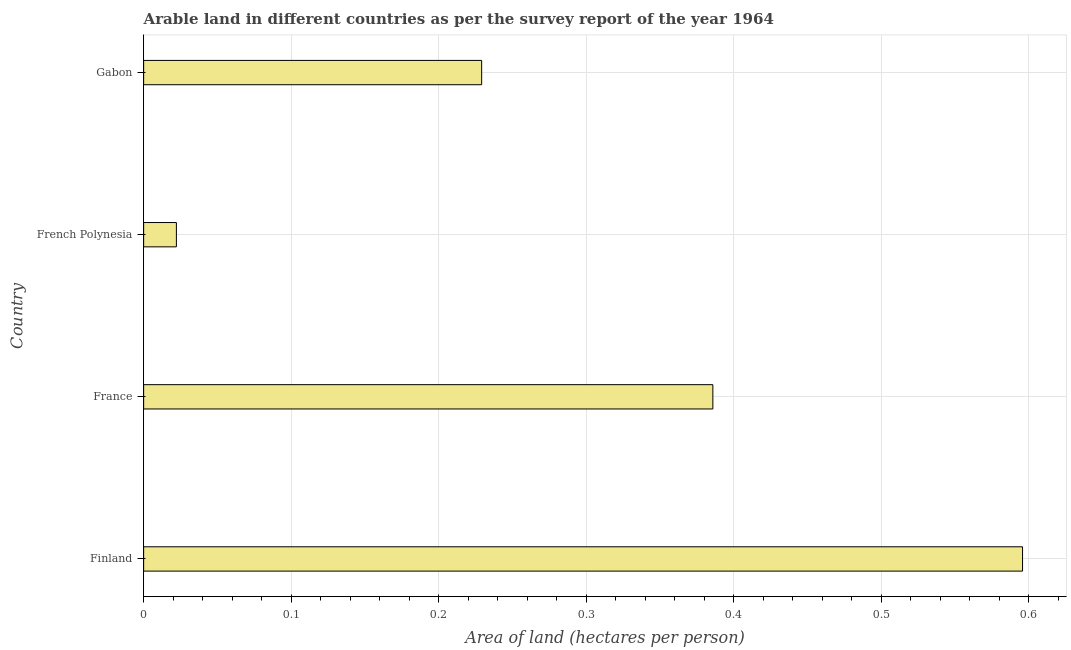Does the graph contain grids?
Provide a short and direct response. Yes. What is the title of the graph?
Offer a terse response. Arable land in different countries as per the survey report of the year 1964. What is the label or title of the X-axis?
Offer a terse response. Area of land (hectares per person). What is the area of arable land in Gabon?
Your answer should be very brief. 0.23. Across all countries, what is the maximum area of arable land?
Offer a very short reply. 0.6. Across all countries, what is the minimum area of arable land?
Give a very brief answer. 0.02. In which country was the area of arable land maximum?
Your answer should be very brief. Finland. In which country was the area of arable land minimum?
Your answer should be compact. French Polynesia. What is the sum of the area of arable land?
Your response must be concise. 1.23. What is the difference between the area of arable land in France and French Polynesia?
Provide a succinct answer. 0.36. What is the average area of arable land per country?
Offer a terse response. 0.31. What is the median area of arable land?
Make the answer very short. 0.31. What is the ratio of the area of arable land in Finland to that in French Polynesia?
Offer a very short reply. 26.85. Is the difference between the area of arable land in France and French Polynesia greater than the difference between any two countries?
Provide a succinct answer. No. What is the difference between the highest and the second highest area of arable land?
Your answer should be compact. 0.21. What is the difference between the highest and the lowest area of arable land?
Provide a succinct answer. 0.57. How many bars are there?
Offer a terse response. 4. Are all the bars in the graph horizontal?
Keep it short and to the point. Yes. How many countries are there in the graph?
Make the answer very short. 4. Are the values on the major ticks of X-axis written in scientific E-notation?
Offer a terse response. No. What is the Area of land (hectares per person) of Finland?
Your answer should be very brief. 0.6. What is the Area of land (hectares per person) of France?
Provide a succinct answer. 0.39. What is the Area of land (hectares per person) in French Polynesia?
Keep it short and to the point. 0.02. What is the Area of land (hectares per person) in Gabon?
Keep it short and to the point. 0.23. What is the difference between the Area of land (hectares per person) in Finland and France?
Provide a short and direct response. 0.21. What is the difference between the Area of land (hectares per person) in Finland and French Polynesia?
Ensure brevity in your answer.  0.57. What is the difference between the Area of land (hectares per person) in Finland and Gabon?
Keep it short and to the point. 0.37. What is the difference between the Area of land (hectares per person) in France and French Polynesia?
Provide a short and direct response. 0.36. What is the difference between the Area of land (hectares per person) in France and Gabon?
Keep it short and to the point. 0.16. What is the difference between the Area of land (hectares per person) in French Polynesia and Gabon?
Your answer should be compact. -0.21. What is the ratio of the Area of land (hectares per person) in Finland to that in France?
Offer a terse response. 1.54. What is the ratio of the Area of land (hectares per person) in Finland to that in French Polynesia?
Your answer should be compact. 26.85. What is the ratio of the Area of land (hectares per person) in Finland to that in Gabon?
Your response must be concise. 2.6. What is the ratio of the Area of land (hectares per person) in France to that in French Polynesia?
Your response must be concise. 17.39. What is the ratio of the Area of land (hectares per person) in France to that in Gabon?
Keep it short and to the point. 1.68. What is the ratio of the Area of land (hectares per person) in French Polynesia to that in Gabon?
Provide a short and direct response. 0.1. 